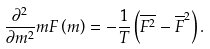<formula> <loc_0><loc_0><loc_500><loc_500>\frac { \partial ^ { 2 } } { \partial m ^ { 2 } } m F \left ( m \right ) = - \frac { 1 } { T } \left ( \overline { F ^ { 2 } } - \overline { F } ^ { 2 } \right ) .</formula> 